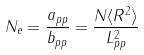Convert formula to latex. <formula><loc_0><loc_0><loc_500><loc_500>N _ { e } = \frac { a _ { p p } } { b _ { p p } } = \frac { N \langle R ^ { 2 } \rangle } { L _ { p p } ^ { 2 } }</formula> 